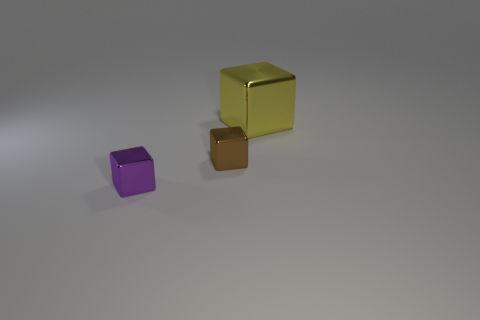Add 3 cyan metallic blocks. How many objects exist? 6 Subtract all large green matte things. Subtract all small purple metal objects. How many objects are left? 2 Add 1 large yellow objects. How many large yellow objects are left? 2 Add 3 big yellow metal objects. How many big yellow metal objects exist? 4 Subtract 0 red cylinders. How many objects are left? 3 